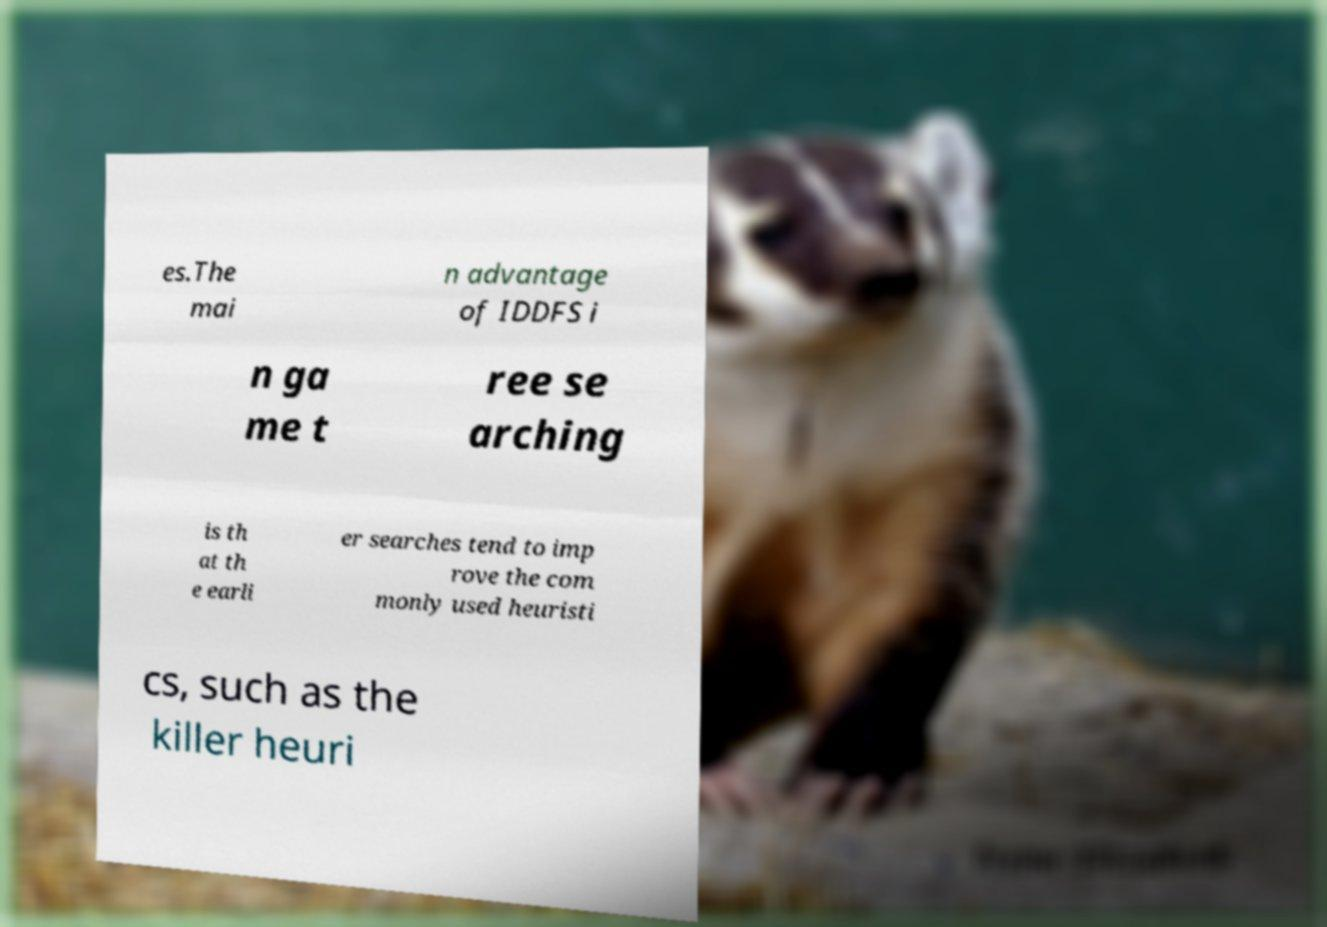For documentation purposes, I need the text within this image transcribed. Could you provide that? es.The mai n advantage of IDDFS i n ga me t ree se arching is th at th e earli er searches tend to imp rove the com monly used heuristi cs, such as the killer heuri 